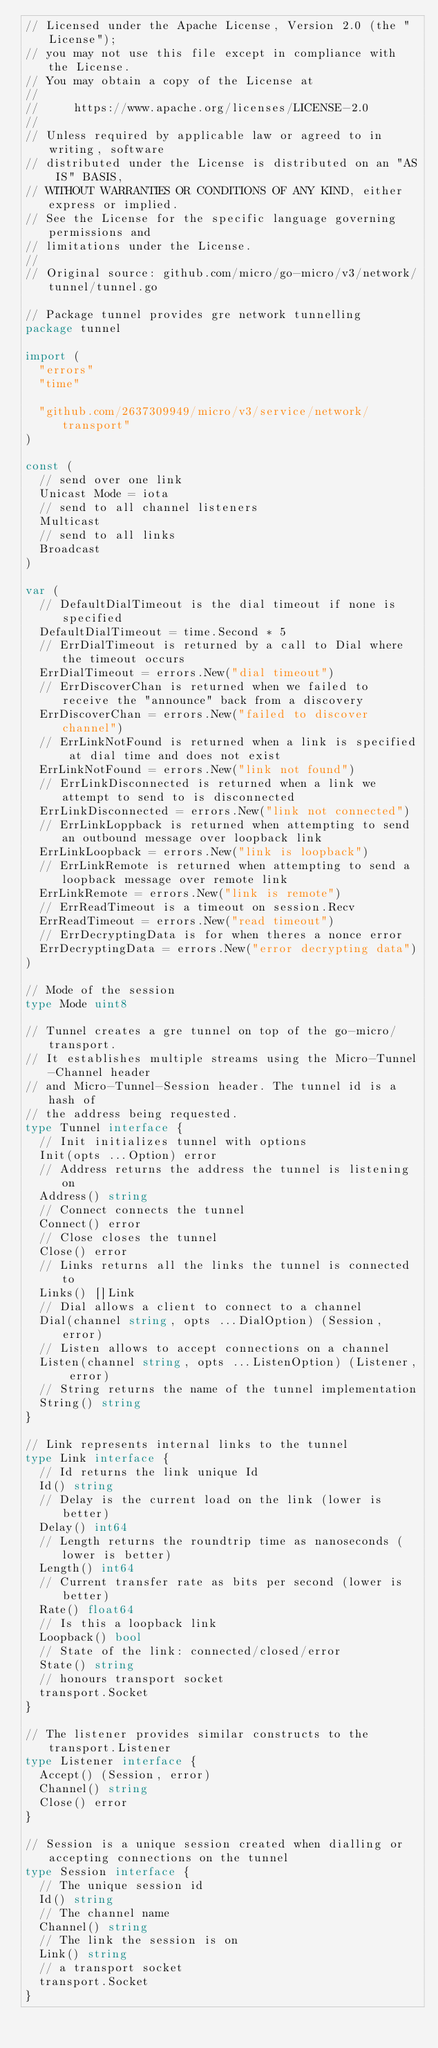Convert code to text. <code><loc_0><loc_0><loc_500><loc_500><_Go_>// Licensed under the Apache License, Version 2.0 (the "License");
// you may not use this file except in compliance with the License.
// You may obtain a copy of the License at
//
//     https://www.apache.org/licenses/LICENSE-2.0
//
// Unless required by applicable law or agreed to in writing, software
// distributed under the License is distributed on an "AS IS" BASIS,
// WITHOUT WARRANTIES OR CONDITIONS OF ANY KIND, either express or implied.
// See the License for the specific language governing permissions and
// limitations under the License.
//
// Original source: github.com/micro/go-micro/v3/network/tunnel/tunnel.go

// Package tunnel provides gre network tunnelling
package tunnel

import (
	"errors"
	"time"

	"github.com/2637309949/micro/v3/service/network/transport"
)

const (
	// send over one link
	Unicast Mode = iota
	// send to all channel listeners
	Multicast
	// send to all links
	Broadcast
)

var (
	// DefaultDialTimeout is the dial timeout if none is specified
	DefaultDialTimeout = time.Second * 5
	// ErrDialTimeout is returned by a call to Dial where the timeout occurs
	ErrDialTimeout = errors.New("dial timeout")
	// ErrDiscoverChan is returned when we failed to receive the "announce" back from a discovery
	ErrDiscoverChan = errors.New("failed to discover channel")
	// ErrLinkNotFound is returned when a link is specified at dial time and does not exist
	ErrLinkNotFound = errors.New("link not found")
	// ErrLinkDisconnected is returned when a link we attempt to send to is disconnected
	ErrLinkDisconnected = errors.New("link not connected")
	// ErrLinkLoppback is returned when attempting to send an outbound message over loopback link
	ErrLinkLoopback = errors.New("link is loopback")
	// ErrLinkRemote is returned when attempting to send a loopback message over remote link
	ErrLinkRemote = errors.New("link is remote")
	// ErrReadTimeout is a timeout on session.Recv
	ErrReadTimeout = errors.New("read timeout")
	// ErrDecryptingData is for when theres a nonce error
	ErrDecryptingData = errors.New("error decrypting data")
)

// Mode of the session
type Mode uint8

// Tunnel creates a gre tunnel on top of the go-micro/transport.
// It establishes multiple streams using the Micro-Tunnel-Channel header
// and Micro-Tunnel-Session header. The tunnel id is a hash of
// the address being requested.
type Tunnel interface {
	// Init initializes tunnel with options
	Init(opts ...Option) error
	// Address returns the address the tunnel is listening on
	Address() string
	// Connect connects the tunnel
	Connect() error
	// Close closes the tunnel
	Close() error
	// Links returns all the links the tunnel is connected to
	Links() []Link
	// Dial allows a client to connect to a channel
	Dial(channel string, opts ...DialOption) (Session, error)
	// Listen allows to accept connections on a channel
	Listen(channel string, opts ...ListenOption) (Listener, error)
	// String returns the name of the tunnel implementation
	String() string
}

// Link represents internal links to the tunnel
type Link interface {
	// Id returns the link unique Id
	Id() string
	// Delay is the current load on the link (lower is better)
	Delay() int64
	// Length returns the roundtrip time as nanoseconds (lower is better)
	Length() int64
	// Current transfer rate as bits per second (lower is better)
	Rate() float64
	// Is this a loopback link
	Loopback() bool
	// State of the link: connected/closed/error
	State() string
	// honours transport socket
	transport.Socket
}

// The listener provides similar constructs to the transport.Listener
type Listener interface {
	Accept() (Session, error)
	Channel() string
	Close() error
}

// Session is a unique session created when dialling or accepting connections on the tunnel
type Session interface {
	// The unique session id
	Id() string
	// The channel name
	Channel() string
	// The link the session is on
	Link() string
	// a transport socket
	transport.Socket
}
</code> 